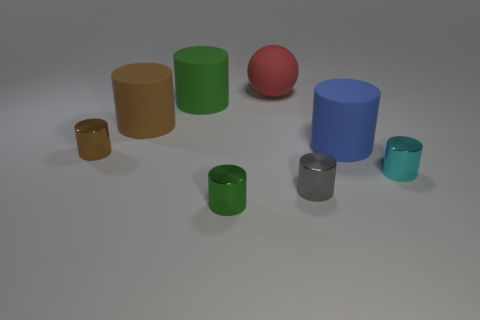Subtract all cyan shiny cylinders. How many cylinders are left? 6 Subtract all gray cylinders. How many cylinders are left? 6 Add 2 yellow objects. How many objects exist? 10 Subtract all blue cylinders. Subtract all brown cubes. How many cylinders are left? 6 Subtract all cylinders. How many objects are left? 1 Add 5 large green objects. How many large green objects are left? 6 Add 4 cyan cylinders. How many cyan cylinders exist? 5 Subtract 0 yellow balls. How many objects are left? 8 Subtract all tiny things. Subtract all small yellow rubber blocks. How many objects are left? 4 